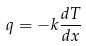<formula> <loc_0><loc_0><loc_500><loc_500>q = - k \frac { d T } { d x }</formula> 